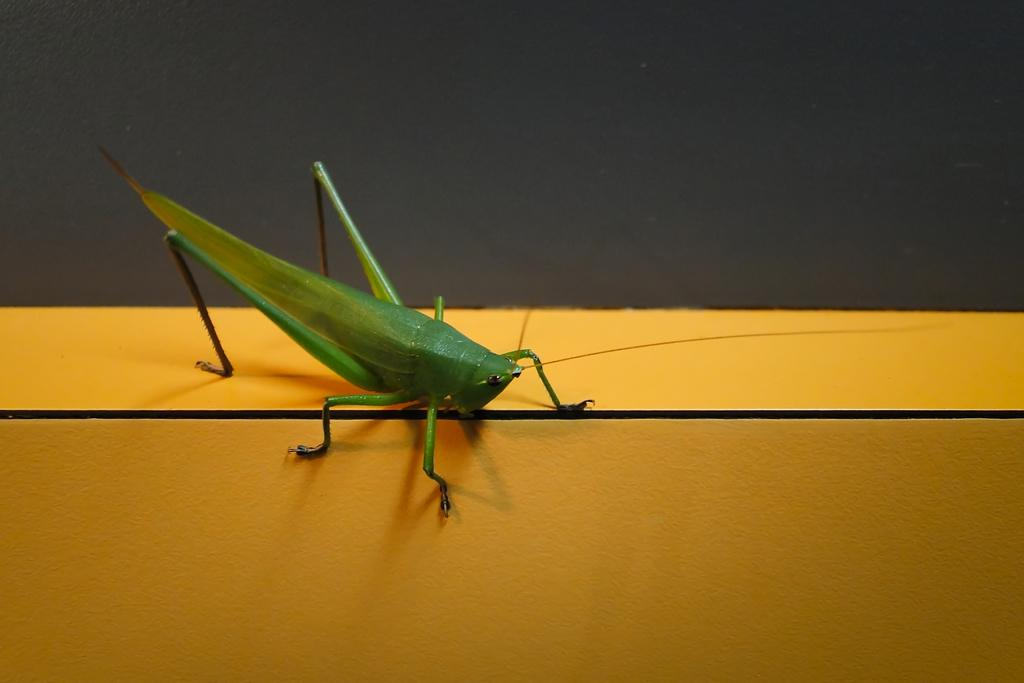What type of insect is in the image? There is a grasshopper in the image. What is the grasshopper resting on or attached to? The grasshopper is on some object. How does the grasshopper show respect to the coil in the image? There is no coil present in the image, and the grasshopper's actions cannot be determined in relation to a coil. 